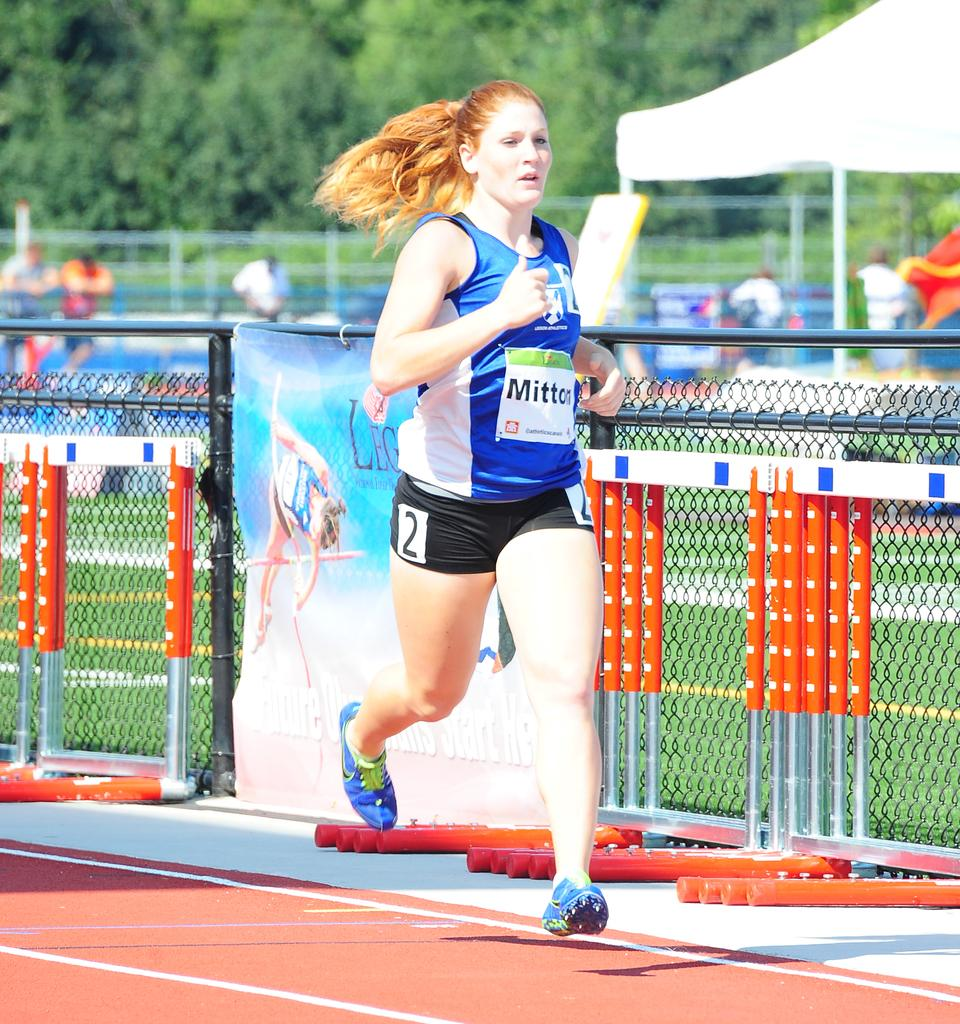Who is the main subject in the image? There is a woman in the image. What is the woman doing in the image? The woman is running. What can be seen in the background of the image? There is a banner, a fence, people, a tent, and trees in the background of the image. What type of appliance can be seen in the woman's hand while she is running? There is no appliance visible in the woman's hand or in the image. 